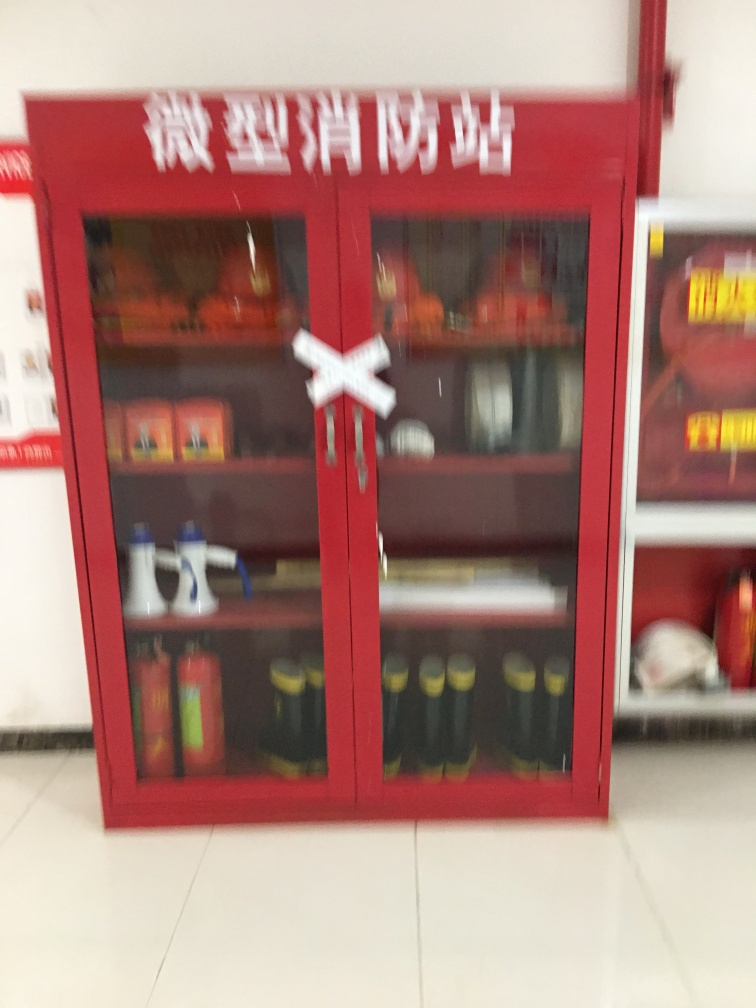What might be the potential hazards associated with the poor visibility of texture details in emergency equipment? Poor visibility of texture details can indicate that the image is out of focus, or the equipment is not properly maintained. In an emergency, this could lead to confusion and delays as firefighters might struggle to quickly identify and access the necessary tools. This reinforces the importance of clear labeling and upkeep of safety equipment. 